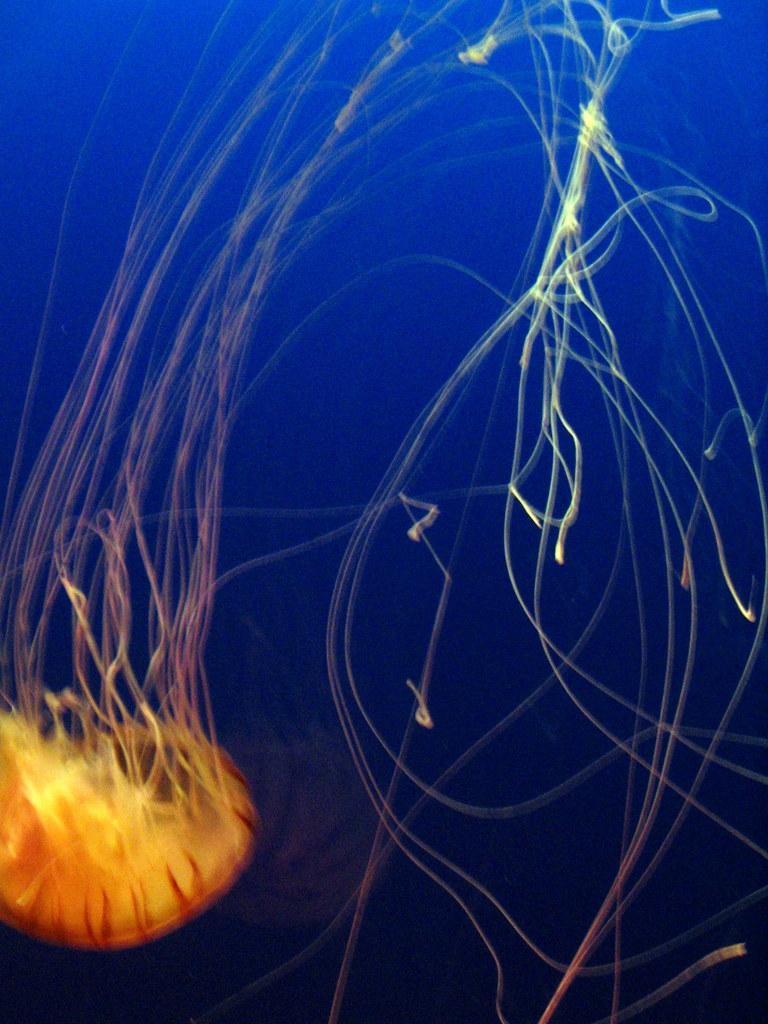In one or two sentences, can you explain what this image depicts? In this image I can see an aquatic animal and I can see blue color background. 